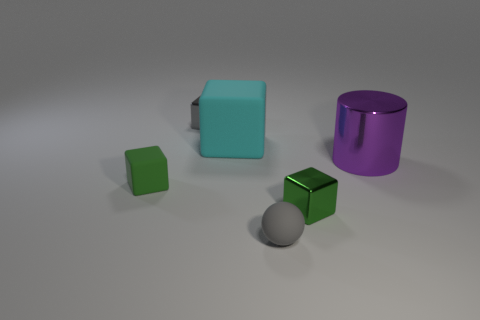Is the shape of the tiny green object that is to the right of the tiny gray metal object the same as the gray object that is behind the gray rubber ball?
Your response must be concise. Yes. What number of things are in front of the green matte thing and to the left of the tiny gray metal cube?
Give a very brief answer. 0. How many other objects are the same size as the cyan rubber block?
Offer a terse response. 1. What is the material of the thing that is behind the large metallic cylinder and in front of the gray shiny object?
Provide a succinct answer. Rubber. Is the color of the small rubber sphere the same as the small shiny thing to the left of the rubber sphere?
Ensure brevity in your answer.  Yes. The green metal object that is the same shape as the gray metal thing is what size?
Your response must be concise. Small. There is a thing that is both behind the tiny rubber block and to the right of the gray rubber thing; what shape is it?
Provide a short and direct response. Cylinder. Does the green shiny object have the same size as the gray thing behind the big purple shiny cylinder?
Your response must be concise. Yes. The large thing that is the same shape as the small gray shiny object is what color?
Your answer should be compact. Cyan. There is a block that is on the right side of the tiny gray rubber ball; is it the same size as the matte object behind the big shiny cylinder?
Provide a short and direct response. No. 